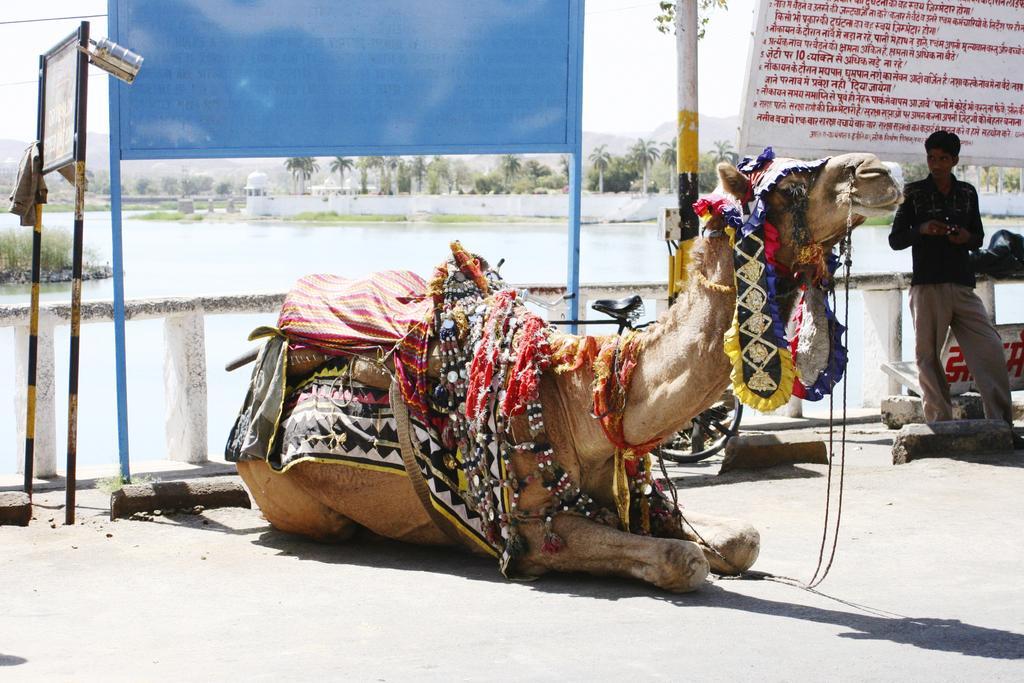Can you describe this image briefly? In this image there is a camel sat on the road surface, beside the camel there is a person standing, behind the person there is a fence, behind the fence there is a river, in the background of the image there are trees and mountains. 